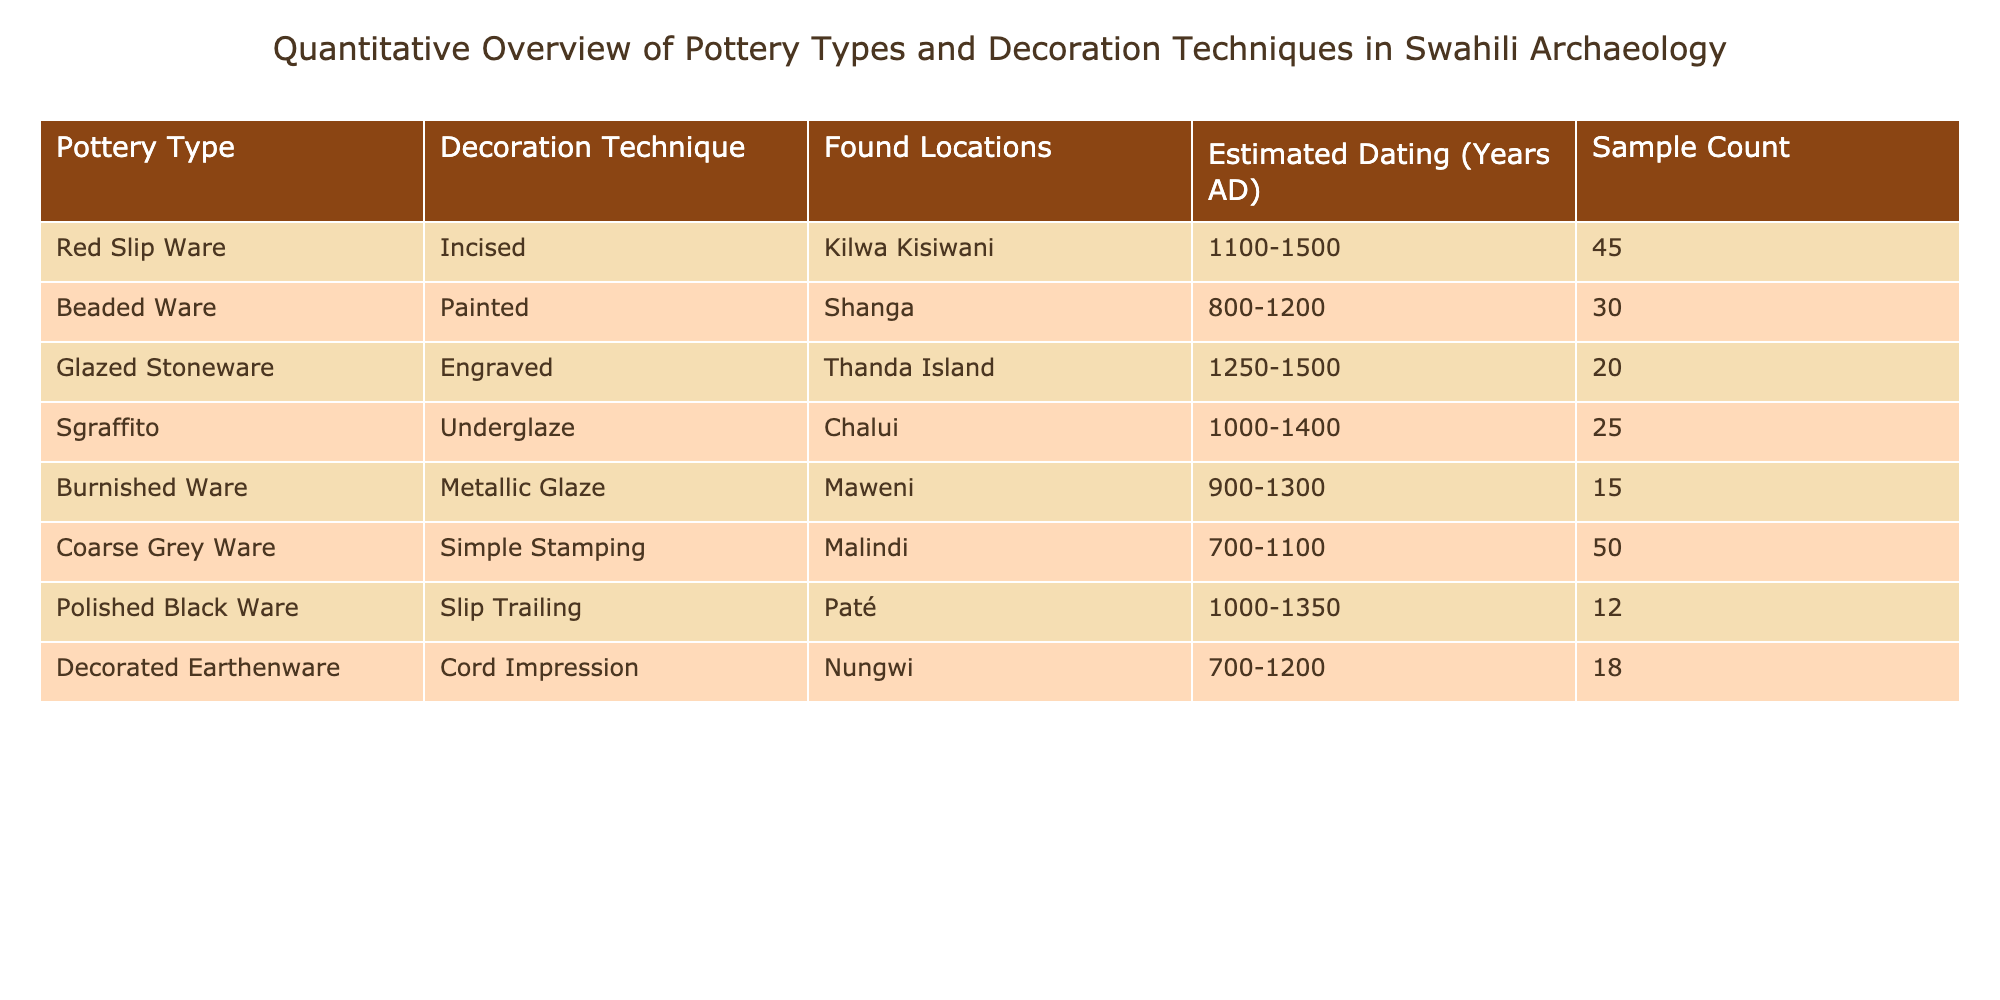What is the sample count of Red Slip Ware? The sample count for Red Slip Ware is listed in the table under the "Sample Count" column next to the "Red Slip Ware" row. The value is 45.
Answer: 45 Which pottery type has the least sample count? To determine the pottery type with the least sample count, we can compare the values in the "Sample Count" column. The smallest value is 12, which corresponds to Polished Black Ware.
Answer: Polished Black Ware Is there any pottery type found in locations from both the 13th and 14th centuries? To answer this, we check the "Estimated Dating" column for pottery types that fall within the years 1200-1400. The date ranges for Glazed Stoneware (1250-1500) and Sgraffito (1000-1400) include both centuries.
Answer: Yes What is the total sample count of pottery types from the location Shanga? The only pottery type from Shanga is Beaded Ware, with a sample count of 30. Therefore, the total sample count for pottery types from Shanga is just 30.
Answer: 30 How many pottery types have a dating range ending in the 14th century? Looking at the "Estimated Dating" column, we find the pottery types with end years of 1400 or later: Red Slip Ware (1500), Glazed Stoneware (1500), and Sgraffito (1400) constitute three pottery types meeting this criterion.
Answer: 3 What is the average estimated dating range across all pottery types in the table? Calculating the average estimated dating involves the midpoints of each pottery type's dating range. For instance, the ranges are: Red Slip Ware (1275), Beaded Ware (1000), Glazed Stoneware (1375), Sgraffito (1200), Burnished Ware (1100), Coarse Grey Ware (900), Polished Black Ware (1175), and Decorated Earthenware (950). Adding these gives 10,000; dividing by 8 yields an average of approximately 1250.
Answer: 1250 Which decoration technique is most frequently associated with pottery found as per the sample count? We can look at the "Decoration Technique" column to find which decoration techniques have the highest sample counts. Simple Stamping is associated with Coarse Grey Ware, which has the highest count of 50.
Answer: Simple Stamping How many pottery types were found in locations that spanned from 700 AD to 1200 AD? We find pottery types with dating ranges that start at or before 1200 and end at or after 700. This includes Coarse Grey Ware, Beaded Ware, and Decorated Earthenware, giving us a total of three pottery types.
Answer: 3 Which pottery type is exclusively painted? The table indicates that only Beaded Ware is associated with the "Painted" decoration technique and no other entry in the table shows painting as a decoration method.
Answer: Beaded Ware 